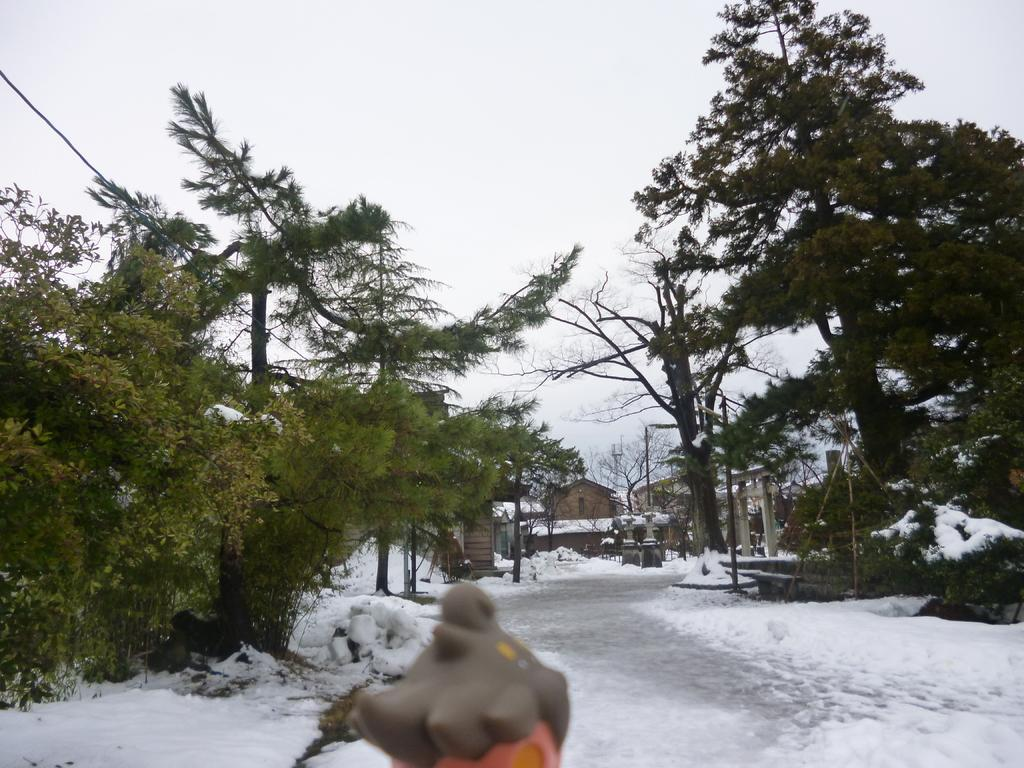What is the condition of the land in the image? The land in the image is covered with snow. What can be seen in the middle of the image? There is an object in the middle of the image. What type of natural features are visible in the background of the image? There are trees in the background of the image. What type of man-made structures can be seen in the background of the image? There are houses in the background of the image. What is visible in the sky in the image? The sky is visible in the background of the image. What type of songs can be heard playing in the background of the image? There is no audio or indication of songs in the image; it is a still image. 